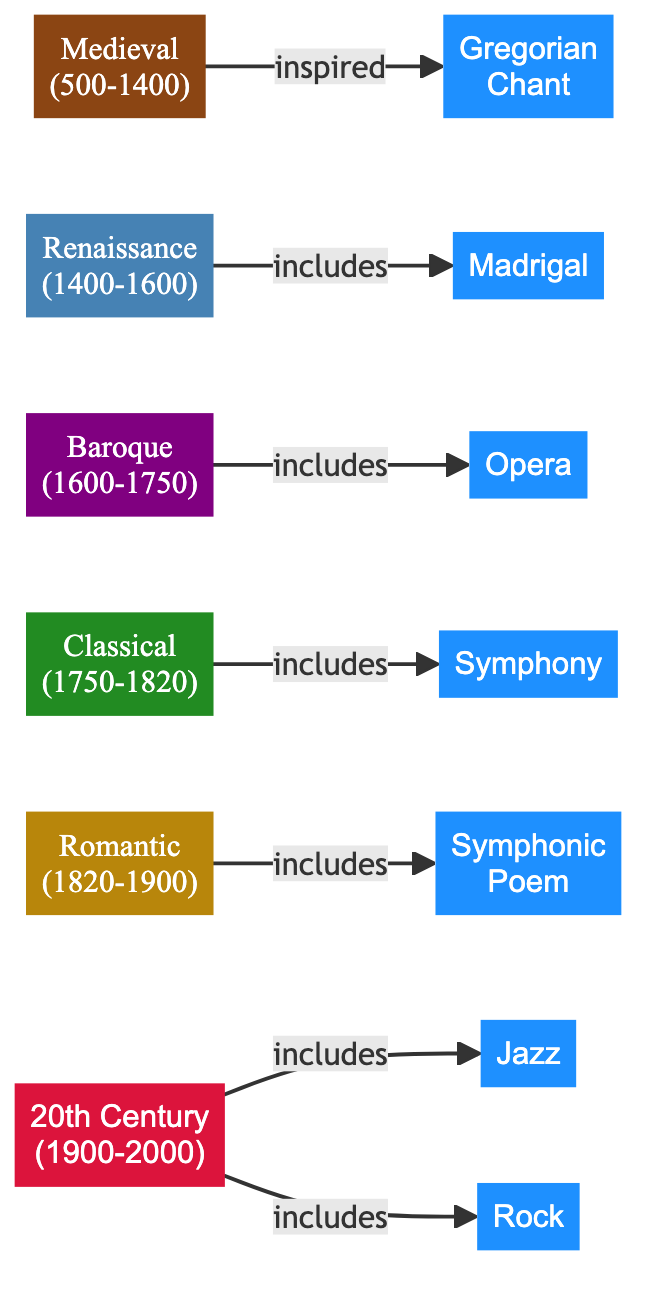What is the earliest music genre represented in the diagram? The earliest node in the diagram is "Medieval (500-1400)", which is associated with the "Gregorian Chant". Therefore, the first music genre presented is Gregorian Chant.
Answer: Gregorian Chant How many music genres are included in the "20th Century" period? The diagram shows two edges coming from the "20th Century" node, leading to the genres "Jazz" and "Rock". Thus, there are two music genres in this period.
Answer: 2 What genre is characterized as a dramatic work set to music for singers and instrumentalists? Referring to the "Baroque" period in the diagram, it indicates that "Opera" is the genre described.
Answer: Opera Which period includes both "Madrigal" and "Symphonic Poem"? The "Renaissance" period is linked to "Madrigal", while "Romantic" period connects to "Symphonic Poem". Therefore, neither period includes both genres. However, they are consecutive periods in the timeline.
Answer: None What is the relationship between "Classical" and "Symphony"? The diagram shows that "Classical" has an edge leading to "Symphony" with the relationship marked as "includes", indicating that symphonies are a part of Classical music.
Answer: includes How many total nodes are shown in the diagram? Counting all distinct periods and genres in the nodes section of the provided data, there are 12 nodes in total that represent various music periods and genres.
Answer: 12 Which genre originated in African American communities? The edge leading from "20th Century" to "Jazz" indicates that Jazz is the genre that originated in African American communities as described.
Answer: Jazz What is a defining characteristic of the "Romantic" period? The description tied to the "Romantic" period in the diagram mentions "expressive emotion and expanded orchestration", indicating its defining characteristics focused on emotional expression.
Answer: Expressive emotion Which music period is known for its clarity and balance? The description for the "Classical" period emphasizes "clarity, balance, and formal structure", which identifies it as the period known for these traits.
Answer: Classical 